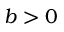<formula> <loc_0><loc_0><loc_500><loc_500>b > 0</formula> 